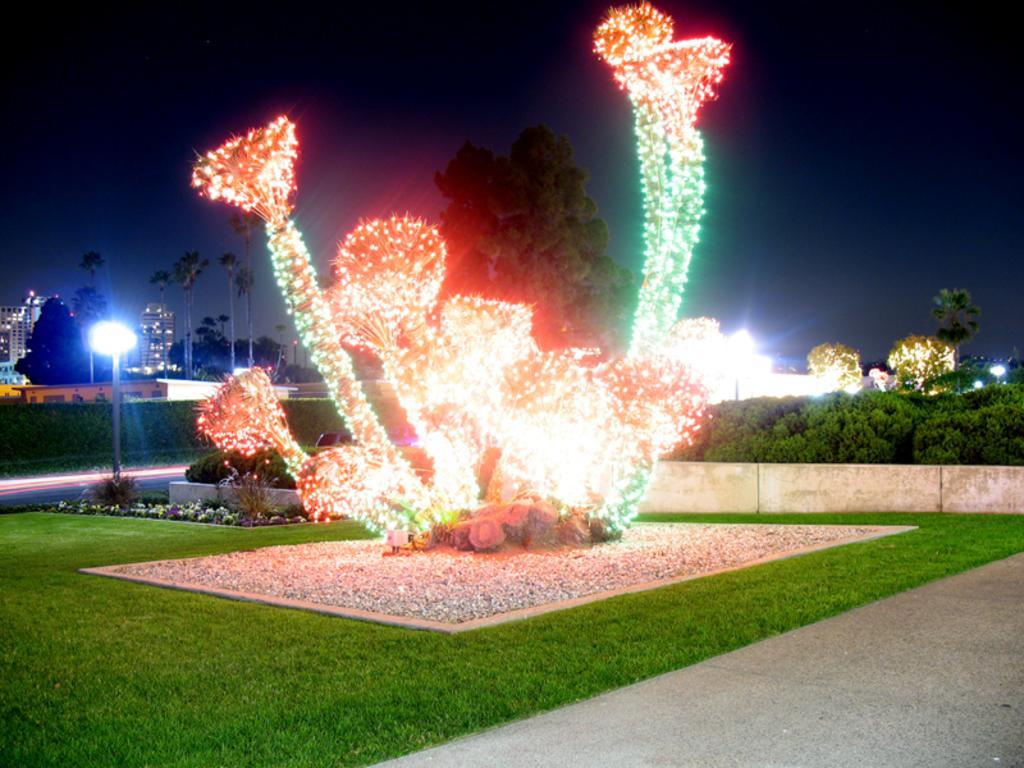How would you summarize this image in a sentence or two? There is a tree decorated with lights and there are few other trees in the background. 